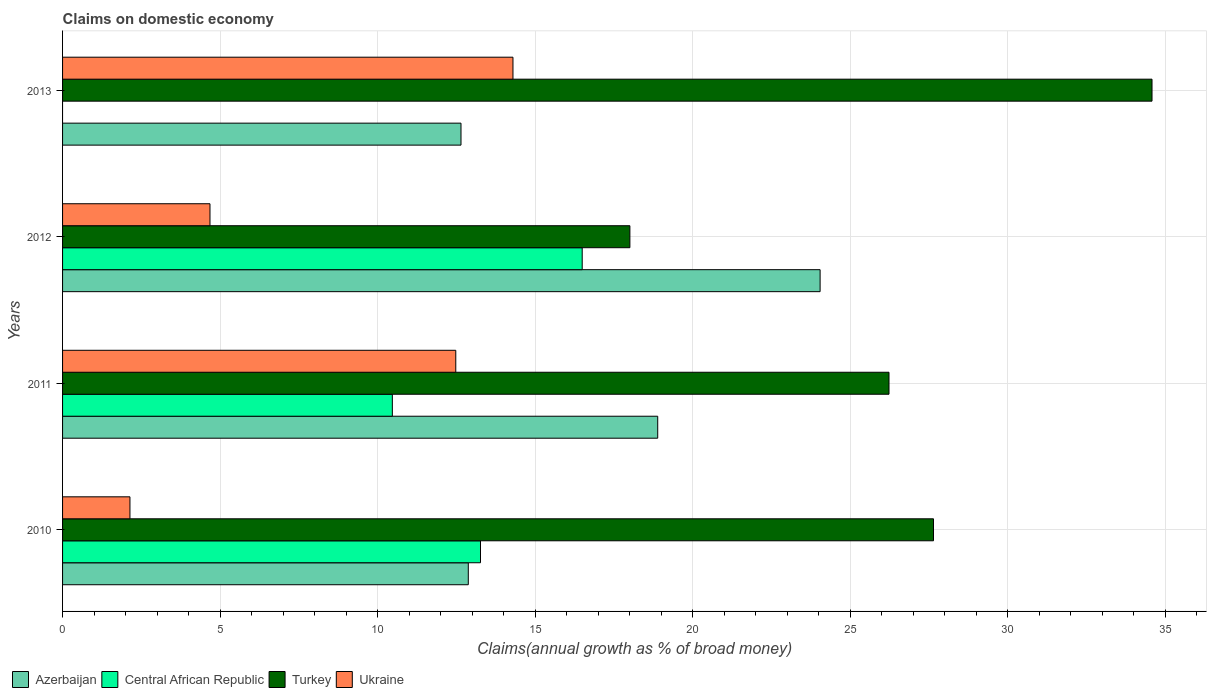How many groups of bars are there?
Offer a terse response. 4. Are the number of bars on each tick of the Y-axis equal?
Give a very brief answer. No. How many bars are there on the 3rd tick from the top?
Provide a short and direct response. 4. How many bars are there on the 2nd tick from the bottom?
Your answer should be compact. 4. What is the label of the 3rd group of bars from the top?
Keep it short and to the point. 2011. In how many cases, is the number of bars for a given year not equal to the number of legend labels?
Provide a short and direct response. 1. What is the percentage of broad money claimed on domestic economy in Azerbaijan in 2013?
Make the answer very short. 12.65. Across all years, what is the maximum percentage of broad money claimed on domestic economy in Central African Republic?
Offer a terse response. 16.5. Across all years, what is the minimum percentage of broad money claimed on domestic economy in Turkey?
Your answer should be very brief. 18.01. What is the total percentage of broad money claimed on domestic economy in Azerbaijan in the graph?
Ensure brevity in your answer.  68.47. What is the difference between the percentage of broad money claimed on domestic economy in Turkey in 2011 and that in 2013?
Your answer should be very brief. -8.35. What is the difference between the percentage of broad money claimed on domestic economy in Central African Republic in 2010 and the percentage of broad money claimed on domestic economy in Turkey in 2012?
Keep it short and to the point. -4.74. What is the average percentage of broad money claimed on domestic economy in Turkey per year?
Your answer should be very brief. 26.62. In the year 2011, what is the difference between the percentage of broad money claimed on domestic economy in Azerbaijan and percentage of broad money claimed on domestic economy in Ukraine?
Provide a short and direct response. 6.41. What is the ratio of the percentage of broad money claimed on domestic economy in Azerbaijan in 2010 to that in 2013?
Ensure brevity in your answer.  1.02. Is the percentage of broad money claimed on domestic economy in Turkey in 2010 less than that in 2012?
Make the answer very short. No. Is the difference between the percentage of broad money claimed on domestic economy in Azerbaijan in 2010 and 2011 greater than the difference between the percentage of broad money claimed on domestic economy in Ukraine in 2010 and 2011?
Provide a succinct answer. Yes. What is the difference between the highest and the second highest percentage of broad money claimed on domestic economy in Central African Republic?
Your answer should be compact. 3.23. What is the difference between the highest and the lowest percentage of broad money claimed on domestic economy in Ukraine?
Keep it short and to the point. 12.16. In how many years, is the percentage of broad money claimed on domestic economy in Turkey greater than the average percentage of broad money claimed on domestic economy in Turkey taken over all years?
Your answer should be compact. 2. How many years are there in the graph?
Provide a succinct answer. 4. Are the values on the major ticks of X-axis written in scientific E-notation?
Provide a short and direct response. No. Does the graph contain any zero values?
Keep it short and to the point. Yes. How many legend labels are there?
Provide a succinct answer. 4. How are the legend labels stacked?
Ensure brevity in your answer.  Horizontal. What is the title of the graph?
Give a very brief answer. Claims on domestic economy. What is the label or title of the X-axis?
Provide a succinct answer. Claims(annual growth as % of broad money). What is the label or title of the Y-axis?
Provide a short and direct response. Years. What is the Claims(annual growth as % of broad money) in Azerbaijan in 2010?
Keep it short and to the point. 12.88. What is the Claims(annual growth as % of broad money) in Central African Republic in 2010?
Make the answer very short. 13.27. What is the Claims(annual growth as % of broad money) in Turkey in 2010?
Make the answer very short. 27.65. What is the Claims(annual growth as % of broad money) in Ukraine in 2010?
Make the answer very short. 2.14. What is the Claims(annual growth as % of broad money) of Azerbaijan in 2011?
Ensure brevity in your answer.  18.89. What is the Claims(annual growth as % of broad money) in Central African Republic in 2011?
Provide a succinct answer. 10.47. What is the Claims(annual growth as % of broad money) of Turkey in 2011?
Ensure brevity in your answer.  26.23. What is the Claims(annual growth as % of broad money) of Ukraine in 2011?
Offer a terse response. 12.48. What is the Claims(annual growth as % of broad money) in Azerbaijan in 2012?
Offer a very short reply. 24.05. What is the Claims(annual growth as % of broad money) in Central African Republic in 2012?
Make the answer very short. 16.5. What is the Claims(annual growth as % of broad money) in Turkey in 2012?
Give a very brief answer. 18.01. What is the Claims(annual growth as % of broad money) of Ukraine in 2012?
Ensure brevity in your answer.  4.68. What is the Claims(annual growth as % of broad money) in Azerbaijan in 2013?
Your answer should be compact. 12.65. What is the Claims(annual growth as % of broad money) of Turkey in 2013?
Offer a terse response. 34.58. What is the Claims(annual growth as % of broad money) in Ukraine in 2013?
Your answer should be very brief. 14.3. Across all years, what is the maximum Claims(annual growth as % of broad money) in Azerbaijan?
Your answer should be compact. 24.05. Across all years, what is the maximum Claims(annual growth as % of broad money) in Central African Republic?
Offer a terse response. 16.5. Across all years, what is the maximum Claims(annual growth as % of broad money) in Turkey?
Keep it short and to the point. 34.58. Across all years, what is the maximum Claims(annual growth as % of broad money) in Ukraine?
Provide a succinct answer. 14.3. Across all years, what is the minimum Claims(annual growth as % of broad money) of Azerbaijan?
Make the answer very short. 12.65. Across all years, what is the minimum Claims(annual growth as % of broad money) of Turkey?
Give a very brief answer. 18.01. Across all years, what is the minimum Claims(annual growth as % of broad money) in Ukraine?
Your response must be concise. 2.14. What is the total Claims(annual growth as % of broad money) in Azerbaijan in the graph?
Give a very brief answer. 68.47. What is the total Claims(annual growth as % of broad money) in Central African Republic in the graph?
Keep it short and to the point. 40.23. What is the total Claims(annual growth as % of broad money) of Turkey in the graph?
Make the answer very short. 106.47. What is the total Claims(annual growth as % of broad money) of Ukraine in the graph?
Your response must be concise. 33.6. What is the difference between the Claims(annual growth as % of broad money) of Azerbaijan in 2010 and that in 2011?
Your answer should be compact. -6.01. What is the difference between the Claims(annual growth as % of broad money) in Central African Republic in 2010 and that in 2011?
Offer a terse response. 2.8. What is the difference between the Claims(annual growth as % of broad money) in Turkey in 2010 and that in 2011?
Give a very brief answer. 1.41. What is the difference between the Claims(annual growth as % of broad money) of Ukraine in 2010 and that in 2011?
Offer a terse response. -10.34. What is the difference between the Claims(annual growth as % of broad money) of Azerbaijan in 2010 and that in 2012?
Make the answer very short. -11.17. What is the difference between the Claims(annual growth as % of broad money) in Central African Republic in 2010 and that in 2012?
Provide a short and direct response. -3.23. What is the difference between the Claims(annual growth as % of broad money) in Turkey in 2010 and that in 2012?
Provide a short and direct response. 9.64. What is the difference between the Claims(annual growth as % of broad money) of Ukraine in 2010 and that in 2012?
Give a very brief answer. -2.54. What is the difference between the Claims(annual growth as % of broad money) of Azerbaijan in 2010 and that in 2013?
Make the answer very short. 0.23. What is the difference between the Claims(annual growth as % of broad money) in Turkey in 2010 and that in 2013?
Offer a terse response. -6.94. What is the difference between the Claims(annual growth as % of broad money) of Ukraine in 2010 and that in 2013?
Make the answer very short. -12.16. What is the difference between the Claims(annual growth as % of broad money) in Azerbaijan in 2011 and that in 2012?
Keep it short and to the point. -5.16. What is the difference between the Claims(annual growth as % of broad money) of Central African Republic in 2011 and that in 2012?
Offer a very short reply. -6.03. What is the difference between the Claims(annual growth as % of broad money) in Turkey in 2011 and that in 2012?
Offer a terse response. 8.23. What is the difference between the Claims(annual growth as % of broad money) of Ukraine in 2011 and that in 2012?
Make the answer very short. 7.8. What is the difference between the Claims(annual growth as % of broad money) in Azerbaijan in 2011 and that in 2013?
Your answer should be very brief. 6.25. What is the difference between the Claims(annual growth as % of broad money) in Turkey in 2011 and that in 2013?
Offer a very short reply. -8.35. What is the difference between the Claims(annual growth as % of broad money) of Ukraine in 2011 and that in 2013?
Offer a very short reply. -1.82. What is the difference between the Claims(annual growth as % of broad money) in Turkey in 2012 and that in 2013?
Ensure brevity in your answer.  -16.57. What is the difference between the Claims(annual growth as % of broad money) of Ukraine in 2012 and that in 2013?
Ensure brevity in your answer.  -9.62. What is the difference between the Claims(annual growth as % of broad money) in Azerbaijan in 2010 and the Claims(annual growth as % of broad money) in Central African Republic in 2011?
Your response must be concise. 2.41. What is the difference between the Claims(annual growth as % of broad money) in Azerbaijan in 2010 and the Claims(annual growth as % of broad money) in Turkey in 2011?
Make the answer very short. -13.36. What is the difference between the Claims(annual growth as % of broad money) in Azerbaijan in 2010 and the Claims(annual growth as % of broad money) in Ukraine in 2011?
Provide a succinct answer. 0.4. What is the difference between the Claims(annual growth as % of broad money) of Central African Republic in 2010 and the Claims(annual growth as % of broad money) of Turkey in 2011?
Give a very brief answer. -12.97. What is the difference between the Claims(annual growth as % of broad money) in Central African Republic in 2010 and the Claims(annual growth as % of broad money) in Ukraine in 2011?
Your response must be concise. 0.78. What is the difference between the Claims(annual growth as % of broad money) of Turkey in 2010 and the Claims(annual growth as % of broad money) of Ukraine in 2011?
Ensure brevity in your answer.  15.16. What is the difference between the Claims(annual growth as % of broad money) in Azerbaijan in 2010 and the Claims(annual growth as % of broad money) in Central African Republic in 2012?
Keep it short and to the point. -3.62. What is the difference between the Claims(annual growth as % of broad money) of Azerbaijan in 2010 and the Claims(annual growth as % of broad money) of Turkey in 2012?
Keep it short and to the point. -5.13. What is the difference between the Claims(annual growth as % of broad money) in Azerbaijan in 2010 and the Claims(annual growth as % of broad money) in Ukraine in 2012?
Ensure brevity in your answer.  8.2. What is the difference between the Claims(annual growth as % of broad money) in Central African Republic in 2010 and the Claims(annual growth as % of broad money) in Turkey in 2012?
Offer a terse response. -4.74. What is the difference between the Claims(annual growth as % of broad money) in Central African Republic in 2010 and the Claims(annual growth as % of broad money) in Ukraine in 2012?
Your answer should be compact. 8.59. What is the difference between the Claims(annual growth as % of broad money) in Turkey in 2010 and the Claims(annual growth as % of broad money) in Ukraine in 2012?
Your response must be concise. 22.97. What is the difference between the Claims(annual growth as % of broad money) in Azerbaijan in 2010 and the Claims(annual growth as % of broad money) in Turkey in 2013?
Your response must be concise. -21.7. What is the difference between the Claims(annual growth as % of broad money) of Azerbaijan in 2010 and the Claims(annual growth as % of broad money) of Ukraine in 2013?
Your answer should be very brief. -1.42. What is the difference between the Claims(annual growth as % of broad money) in Central African Republic in 2010 and the Claims(annual growth as % of broad money) in Turkey in 2013?
Provide a short and direct response. -21.32. What is the difference between the Claims(annual growth as % of broad money) of Central African Republic in 2010 and the Claims(annual growth as % of broad money) of Ukraine in 2013?
Your answer should be very brief. -1.03. What is the difference between the Claims(annual growth as % of broad money) in Turkey in 2010 and the Claims(annual growth as % of broad money) in Ukraine in 2013?
Your answer should be very brief. 13.35. What is the difference between the Claims(annual growth as % of broad money) in Azerbaijan in 2011 and the Claims(annual growth as % of broad money) in Central African Republic in 2012?
Ensure brevity in your answer.  2.4. What is the difference between the Claims(annual growth as % of broad money) of Azerbaijan in 2011 and the Claims(annual growth as % of broad money) of Turkey in 2012?
Make the answer very short. 0.88. What is the difference between the Claims(annual growth as % of broad money) in Azerbaijan in 2011 and the Claims(annual growth as % of broad money) in Ukraine in 2012?
Your response must be concise. 14.21. What is the difference between the Claims(annual growth as % of broad money) in Central African Republic in 2011 and the Claims(annual growth as % of broad money) in Turkey in 2012?
Your answer should be compact. -7.54. What is the difference between the Claims(annual growth as % of broad money) of Central African Republic in 2011 and the Claims(annual growth as % of broad money) of Ukraine in 2012?
Offer a terse response. 5.79. What is the difference between the Claims(annual growth as % of broad money) of Turkey in 2011 and the Claims(annual growth as % of broad money) of Ukraine in 2012?
Your answer should be compact. 21.55. What is the difference between the Claims(annual growth as % of broad money) in Azerbaijan in 2011 and the Claims(annual growth as % of broad money) in Turkey in 2013?
Your response must be concise. -15.69. What is the difference between the Claims(annual growth as % of broad money) in Azerbaijan in 2011 and the Claims(annual growth as % of broad money) in Ukraine in 2013?
Your response must be concise. 4.6. What is the difference between the Claims(annual growth as % of broad money) of Central African Republic in 2011 and the Claims(annual growth as % of broad money) of Turkey in 2013?
Offer a very short reply. -24.12. What is the difference between the Claims(annual growth as % of broad money) in Central African Republic in 2011 and the Claims(annual growth as % of broad money) in Ukraine in 2013?
Keep it short and to the point. -3.83. What is the difference between the Claims(annual growth as % of broad money) of Turkey in 2011 and the Claims(annual growth as % of broad money) of Ukraine in 2013?
Make the answer very short. 11.94. What is the difference between the Claims(annual growth as % of broad money) in Azerbaijan in 2012 and the Claims(annual growth as % of broad money) in Turkey in 2013?
Your answer should be very brief. -10.54. What is the difference between the Claims(annual growth as % of broad money) in Azerbaijan in 2012 and the Claims(annual growth as % of broad money) in Ukraine in 2013?
Offer a very short reply. 9.75. What is the difference between the Claims(annual growth as % of broad money) in Central African Republic in 2012 and the Claims(annual growth as % of broad money) in Turkey in 2013?
Provide a succinct answer. -18.09. What is the difference between the Claims(annual growth as % of broad money) of Central African Republic in 2012 and the Claims(annual growth as % of broad money) of Ukraine in 2013?
Make the answer very short. 2.2. What is the difference between the Claims(annual growth as % of broad money) of Turkey in 2012 and the Claims(annual growth as % of broad money) of Ukraine in 2013?
Offer a terse response. 3.71. What is the average Claims(annual growth as % of broad money) of Azerbaijan per year?
Offer a very short reply. 17.12. What is the average Claims(annual growth as % of broad money) in Central African Republic per year?
Your answer should be compact. 10.06. What is the average Claims(annual growth as % of broad money) of Turkey per year?
Make the answer very short. 26.62. What is the average Claims(annual growth as % of broad money) of Ukraine per year?
Your response must be concise. 8.4. In the year 2010, what is the difference between the Claims(annual growth as % of broad money) in Azerbaijan and Claims(annual growth as % of broad money) in Central African Republic?
Give a very brief answer. -0.39. In the year 2010, what is the difference between the Claims(annual growth as % of broad money) of Azerbaijan and Claims(annual growth as % of broad money) of Turkey?
Offer a very short reply. -14.77. In the year 2010, what is the difference between the Claims(annual growth as % of broad money) of Azerbaijan and Claims(annual growth as % of broad money) of Ukraine?
Keep it short and to the point. 10.74. In the year 2010, what is the difference between the Claims(annual growth as % of broad money) of Central African Republic and Claims(annual growth as % of broad money) of Turkey?
Make the answer very short. -14.38. In the year 2010, what is the difference between the Claims(annual growth as % of broad money) in Central African Republic and Claims(annual growth as % of broad money) in Ukraine?
Keep it short and to the point. 11.13. In the year 2010, what is the difference between the Claims(annual growth as % of broad money) of Turkey and Claims(annual growth as % of broad money) of Ukraine?
Your answer should be very brief. 25.51. In the year 2011, what is the difference between the Claims(annual growth as % of broad money) in Azerbaijan and Claims(annual growth as % of broad money) in Central African Republic?
Offer a very short reply. 8.42. In the year 2011, what is the difference between the Claims(annual growth as % of broad money) in Azerbaijan and Claims(annual growth as % of broad money) in Turkey?
Make the answer very short. -7.34. In the year 2011, what is the difference between the Claims(annual growth as % of broad money) in Azerbaijan and Claims(annual growth as % of broad money) in Ukraine?
Provide a succinct answer. 6.41. In the year 2011, what is the difference between the Claims(annual growth as % of broad money) in Central African Republic and Claims(annual growth as % of broad money) in Turkey?
Ensure brevity in your answer.  -15.77. In the year 2011, what is the difference between the Claims(annual growth as % of broad money) of Central African Republic and Claims(annual growth as % of broad money) of Ukraine?
Provide a short and direct response. -2.01. In the year 2011, what is the difference between the Claims(annual growth as % of broad money) in Turkey and Claims(annual growth as % of broad money) in Ukraine?
Make the answer very short. 13.75. In the year 2012, what is the difference between the Claims(annual growth as % of broad money) of Azerbaijan and Claims(annual growth as % of broad money) of Central African Republic?
Ensure brevity in your answer.  7.55. In the year 2012, what is the difference between the Claims(annual growth as % of broad money) in Azerbaijan and Claims(annual growth as % of broad money) in Turkey?
Make the answer very short. 6.04. In the year 2012, what is the difference between the Claims(annual growth as % of broad money) of Azerbaijan and Claims(annual growth as % of broad money) of Ukraine?
Provide a short and direct response. 19.37. In the year 2012, what is the difference between the Claims(annual growth as % of broad money) of Central African Republic and Claims(annual growth as % of broad money) of Turkey?
Offer a very short reply. -1.51. In the year 2012, what is the difference between the Claims(annual growth as % of broad money) in Central African Republic and Claims(annual growth as % of broad money) in Ukraine?
Provide a succinct answer. 11.82. In the year 2012, what is the difference between the Claims(annual growth as % of broad money) of Turkey and Claims(annual growth as % of broad money) of Ukraine?
Offer a very short reply. 13.33. In the year 2013, what is the difference between the Claims(annual growth as % of broad money) of Azerbaijan and Claims(annual growth as % of broad money) of Turkey?
Give a very brief answer. -21.94. In the year 2013, what is the difference between the Claims(annual growth as % of broad money) in Azerbaijan and Claims(annual growth as % of broad money) in Ukraine?
Make the answer very short. -1.65. In the year 2013, what is the difference between the Claims(annual growth as % of broad money) in Turkey and Claims(annual growth as % of broad money) in Ukraine?
Make the answer very short. 20.29. What is the ratio of the Claims(annual growth as % of broad money) in Azerbaijan in 2010 to that in 2011?
Offer a terse response. 0.68. What is the ratio of the Claims(annual growth as % of broad money) of Central African Republic in 2010 to that in 2011?
Provide a succinct answer. 1.27. What is the ratio of the Claims(annual growth as % of broad money) in Turkey in 2010 to that in 2011?
Keep it short and to the point. 1.05. What is the ratio of the Claims(annual growth as % of broad money) in Ukraine in 2010 to that in 2011?
Provide a short and direct response. 0.17. What is the ratio of the Claims(annual growth as % of broad money) of Azerbaijan in 2010 to that in 2012?
Keep it short and to the point. 0.54. What is the ratio of the Claims(annual growth as % of broad money) in Central African Republic in 2010 to that in 2012?
Make the answer very short. 0.8. What is the ratio of the Claims(annual growth as % of broad money) in Turkey in 2010 to that in 2012?
Your response must be concise. 1.54. What is the ratio of the Claims(annual growth as % of broad money) in Ukraine in 2010 to that in 2012?
Offer a very short reply. 0.46. What is the ratio of the Claims(annual growth as % of broad money) of Azerbaijan in 2010 to that in 2013?
Your answer should be very brief. 1.02. What is the ratio of the Claims(annual growth as % of broad money) in Turkey in 2010 to that in 2013?
Provide a succinct answer. 0.8. What is the ratio of the Claims(annual growth as % of broad money) of Ukraine in 2010 to that in 2013?
Keep it short and to the point. 0.15. What is the ratio of the Claims(annual growth as % of broad money) of Azerbaijan in 2011 to that in 2012?
Make the answer very short. 0.79. What is the ratio of the Claims(annual growth as % of broad money) of Central African Republic in 2011 to that in 2012?
Your answer should be compact. 0.63. What is the ratio of the Claims(annual growth as % of broad money) in Turkey in 2011 to that in 2012?
Make the answer very short. 1.46. What is the ratio of the Claims(annual growth as % of broad money) in Ukraine in 2011 to that in 2012?
Your response must be concise. 2.67. What is the ratio of the Claims(annual growth as % of broad money) in Azerbaijan in 2011 to that in 2013?
Your answer should be very brief. 1.49. What is the ratio of the Claims(annual growth as % of broad money) in Turkey in 2011 to that in 2013?
Keep it short and to the point. 0.76. What is the ratio of the Claims(annual growth as % of broad money) of Ukraine in 2011 to that in 2013?
Provide a short and direct response. 0.87. What is the ratio of the Claims(annual growth as % of broad money) of Azerbaijan in 2012 to that in 2013?
Give a very brief answer. 1.9. What is the ratio of the Claims(annual growth as % of broad money) in Turkey in 2012 to that in 2013?
Give a very brief answer. 0.52. What is the ratio of the Claims(annual growth as % of broad money) in Ukraine in 2012 to that in 2013?
Provide a succinct answer. 0.33. What is the difference between the highest and the second highest Claims(annual growth as % of broad money) of Azerbaijan?
Offer a terse response. 5.16. What is the difference between the highest and the second highest Claims(annual growth as % of broad money) in Central African Republic?
Your response must be concise. 3.23. What is the difference between the highest and the second highest Claims(annual growth as % of broad money) of Turkey?
Your answer should be compact. 6.94. What is the difference between the highest and the second highest Claims(annual growth as % of broad money) in Ukraine?
Keep it short and to the point. 1.82. What is the difference between the highest and the lowest Claims(annual growth as % of broad money) in Azerbaijan?
Ensure brevity in your answer.  11.4. What is the difference between the highest and the lowest Claims(annual growth as % of broad money) in Central African Republic?
Your answer should be very brief. 16.5. What is the difference between the highest and the lowest Claims(annual growth as % of broad money) of Turkey?
Your answer should be compact. 16.57. What is the difference between the highest and the lowest Claims(annual growth as % of broad money) in Ukraine?
Keep it short and to the point. 12.16. 